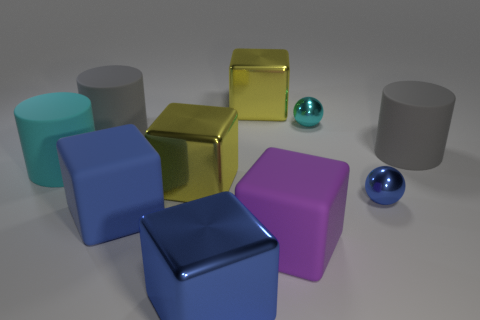What size is the purple cube that is the same material as the big cyan thing?
Ensure brevity in your answer.  Large. What number of blue metal spheres are right of the gray rubber cylinder on the left side of the small object to the left of the tiny blue metal sphere?
Offer a terse response. 1. What number of yellow metal cubes are behind the cyan object that is behind the large cyan matte cylinder?
Give a very brief answer. 1. There is a large blue rubber cube; how many blue matte things are to the left of it?
Offer a very short reply. 0. How many other things are there of the same size as the blue matte thing?
Offer a very short reply. 7. What is the size of the blue matte thing that is the same shape as the purple rubber object?
Provide a short and direct response. Large. There is a tiny metallic object behind the big cyan rubber cylinder; what shape is it?
Your response must be concise. Sphere. There is a large rubber cylinder in front of the large matte object right of the small cyan metallic ball; what is its color?
Provide a short and direct response. Cyan. How many things are rubber cylinders that are to the right of the big cyan cylinder or large blue cylinders?
Provide a short and direct response. 2. There is a purple block; does it have the same size as the gray cylinder that is on the left side of the small blue thing?
Provide a short and direct response. Yes. 